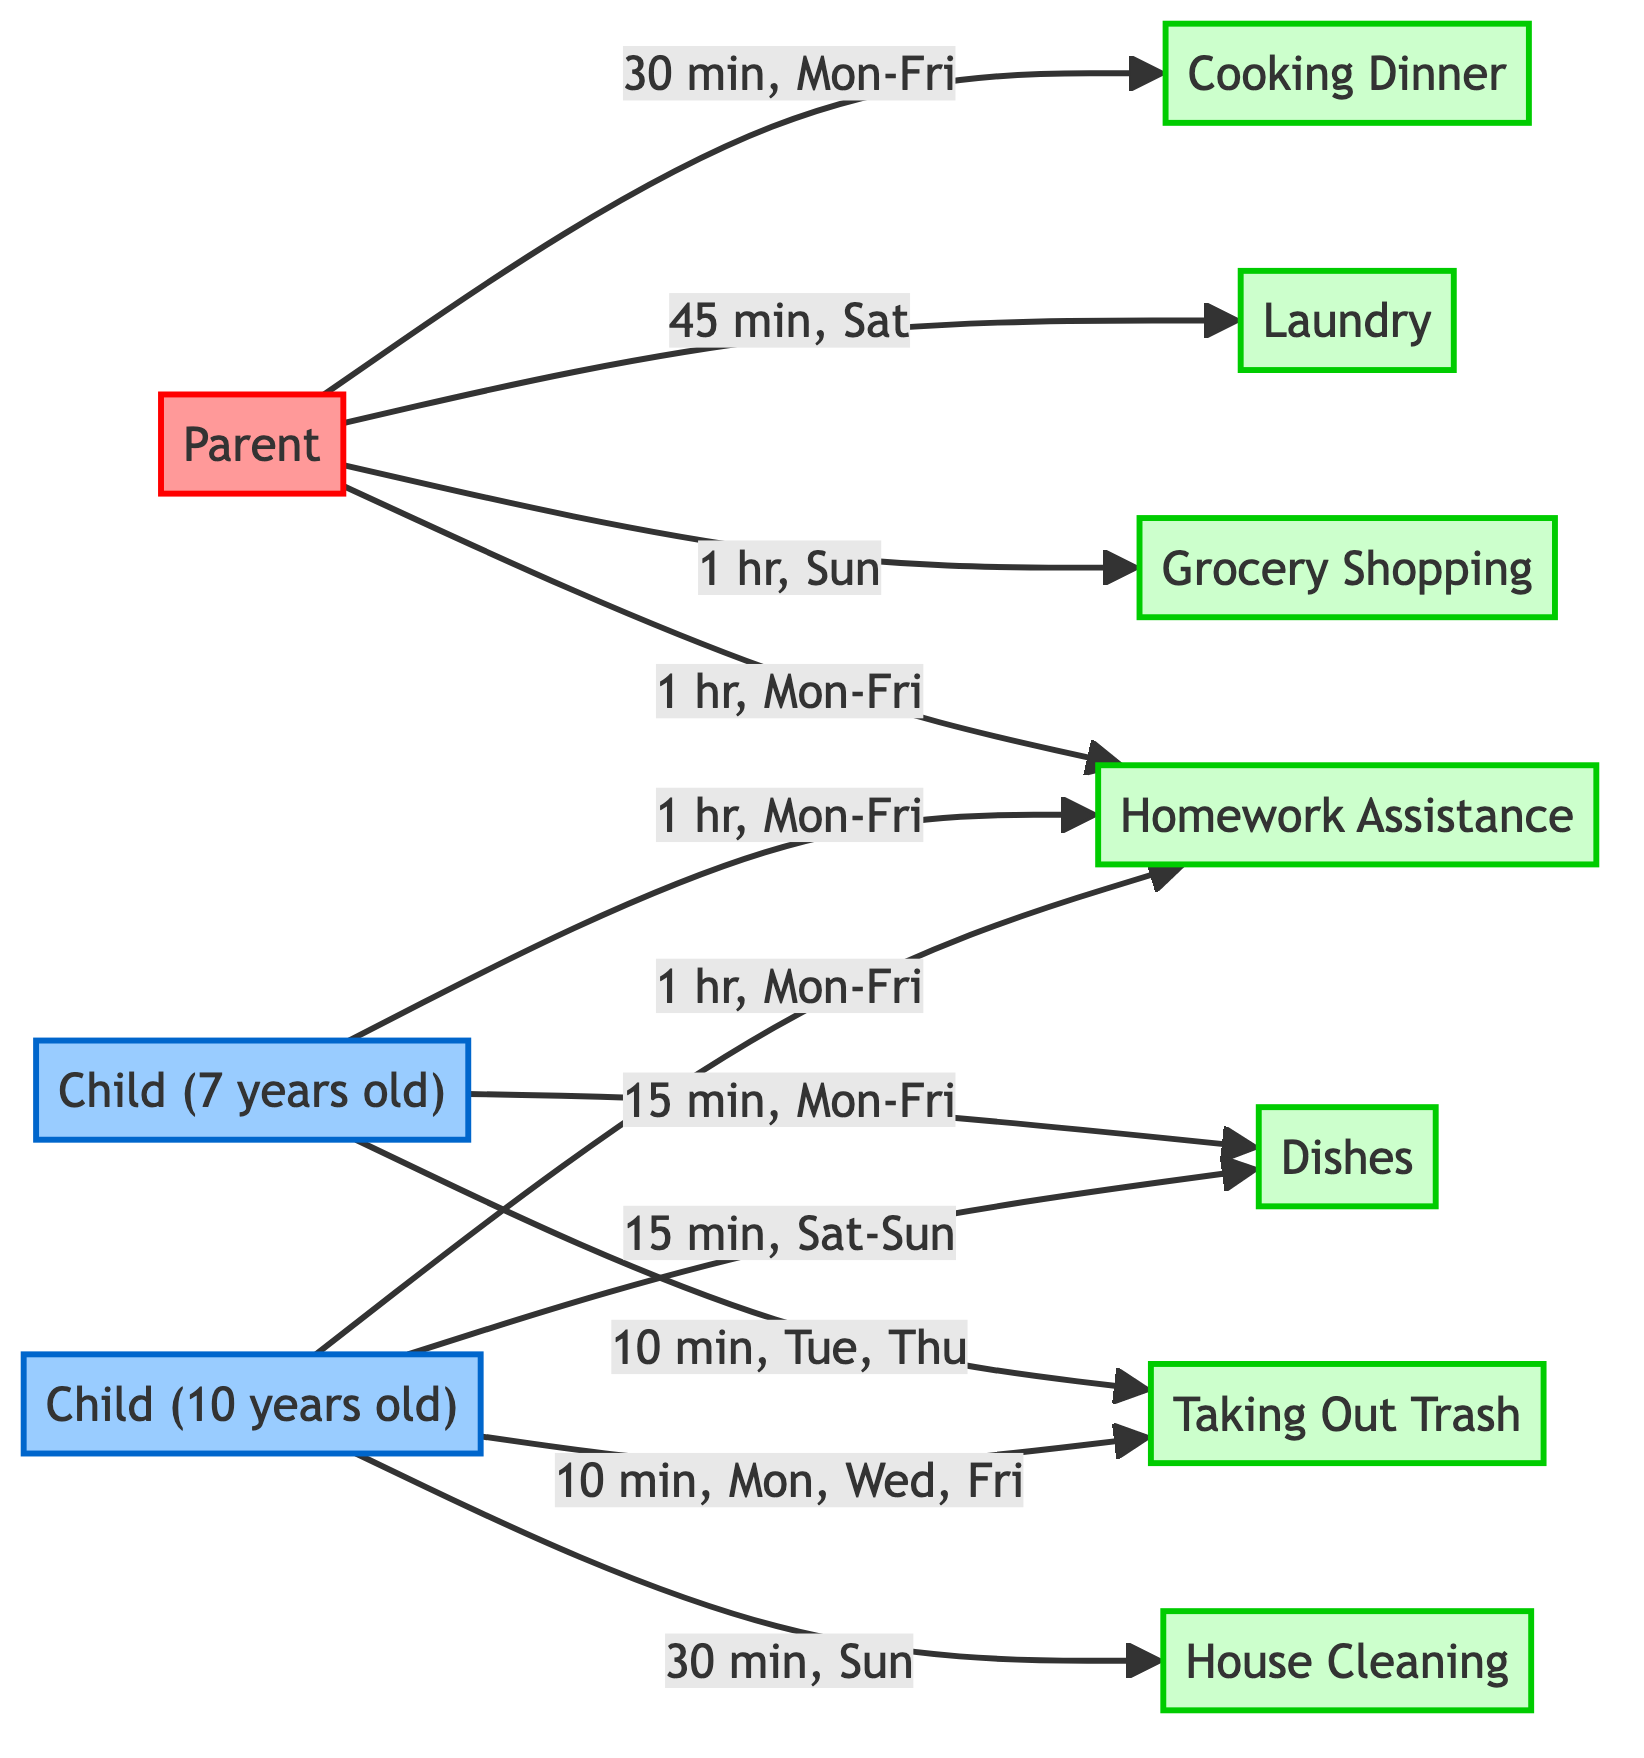What is the duration for cooking dinner? The diagram specifies that the parent is responsible for cooking dinner for "30 min, Mon-Fri". This is taken directly from the arrow pointing from "Parent" to "Cooking Dinner".
Answer: 30 min, Mon-Fri How often does the 7-year-old child take out the trash? The diagram indicates that the 7-year-old child takes out the trash for "10 min, Tue, Thu". This is confirmed by the specific connection from "Child (7 years old)" to "Taking Out Trash".
Answer: 10 min, Tue, Thu What is the total frequency of dishes being done by both children? The 7-year-old does the dishes for "15 min, Mon-Fri" (5 days), and the 10-year-old does the dishes for "15 min, Sat-Sun" (2 days). So, the total frequency is 5 + 2 = 7.
Answer: 7 Who does the majority of the homework assistance? Both children do homework for "1 hr, Mon-Fri", and since each child does the same amount, the parent does not assist in this chore, so the combined effort makes the children equal. However, since the parent isn't involved, the children do it predominantly.
Answer: Both children How many chores does the parent handle? The chart shows that the parent is responsible for three chores: cooking dinner, laundry, and grocery shopping. Each connection to these chores from the parent node counts them.
Answer: 3 What is the total duration of cleaning by the 10-year-old child? The diagram indicates that the 10-year-old does house cleaning for "30 min, Sun". This is the only instance recorded for the child under the cleaning task, directly leading from "Child (10 years old)" to "House Cleaning".
Answer: 30 min, Sun Which child has a longer duration listed for trash duties? By reviewing the diagram, the 10-year-old takes out the trash for "10 min, Mon, Wed, Fri" (3 days), totaling 30 minutes. The 7-year-old takes out the trash for "10 min, Tue, Thu", totaling 20 minutes. Thus, the 10-year-old has a longer listed duration for trash duties.
Answer: Child (10 years old) What is the duration of laundry on Saturday? The diagram provides the information that the parent does laundry on Saturday for "45 min, Sat". This can be confirmed from the direct connection from "Parent" to "Laundry".
Answer: 45 min, Sat How many total tasks are assigned to the children? The diagram lists 6 distinct tasks: dishes, trash, cleaning, and homework, repeated for each child. There are two children performing tasks listed, so if we count each task per child, we find the total assigned tasks. Child (7 years old) has 3 tasks, and Child (10 years old) has 4 tasks, making it 7 tasks total over both children.
Answer: 7 